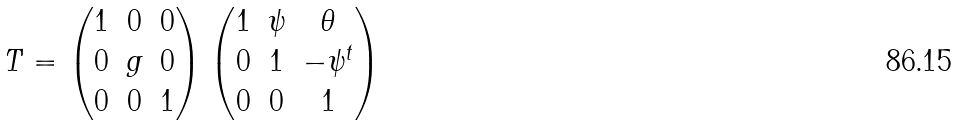Convert formula to latex. <formula><loc_0><loc_0><loc_500><loc_500>T = \begin{pmatrix} 1 & 0 & 0 \\ 0 & g & 0 \\ 0 & 0 & 1 \end{pmatrix} \begin{pmatrix} 1 & \psi & \theta \\ 0 & 1 & - \psi ^ { t } \\ 0 & 0 & 1 \end{pmatrix}</formula> 